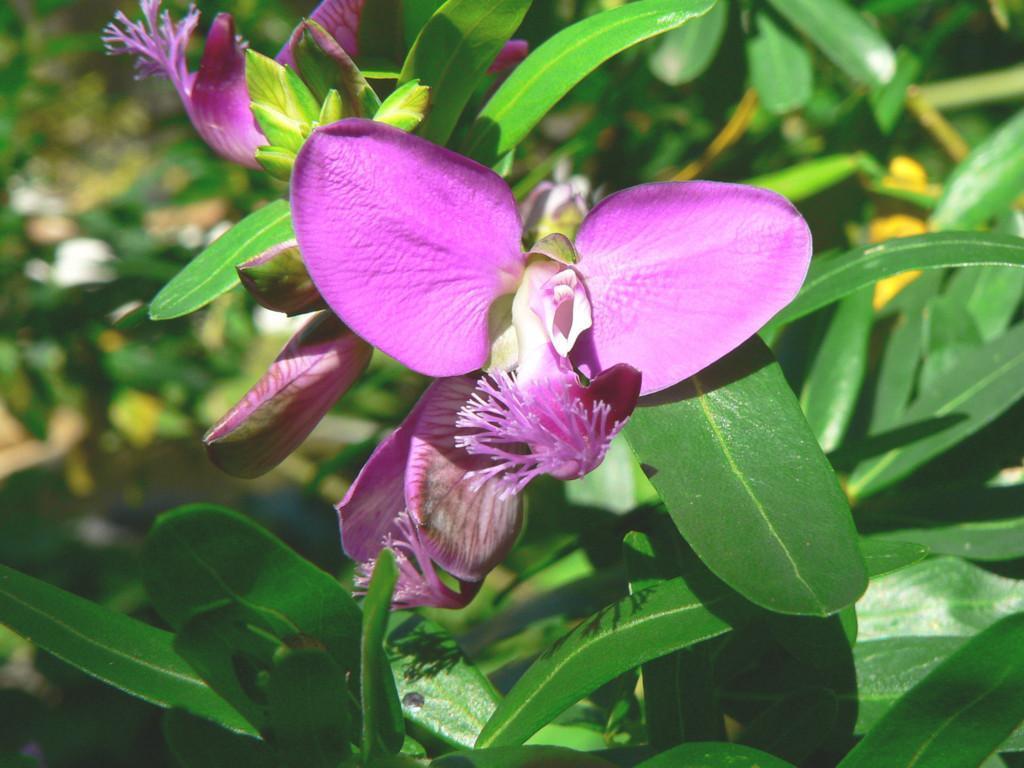Can you describe this image briefly? The picture consists of a plant. In the foreground we can see leaves and flowers. In the background there is greenery. 